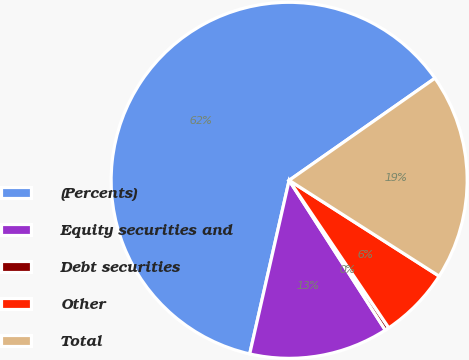Convert chart to OTSL. <chart><loc_0><loc_0><loc_500><loc_500><pie_chart><fcel>(Percents)<fcel>Equity securities and<fcel>Debt securities<fcel>Other<fcel>Total<nl><fcel>61.72%<fcel>12.64%<fcel>0.37%<fcel>6.5%<fcel>18.77%<nl></chart> 